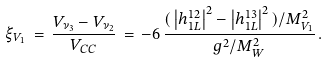Convert formula to latex. <formula><loc_0><loc_0><loc_500><loc_500>\xi _ { V _ { 1 } } \, = \, \frac { V _ { \nu _ { 3 } } - V _ { \nu _ { 2 } } } { V _ { C C } } \, = \, - 6 \, \frac { ( \, \left | h _ { 1 L } ^ { 1 2 } \right | ^ { 2 } - \left | h _ { 1 L } ^ { 1 3 } \right | ^ { 2 } \, ) / M _ { V _ { 1 } } ^ { 2 } } { g ^ { 2 } / M _ { W } ^ { 2 } } \, .</formula> 